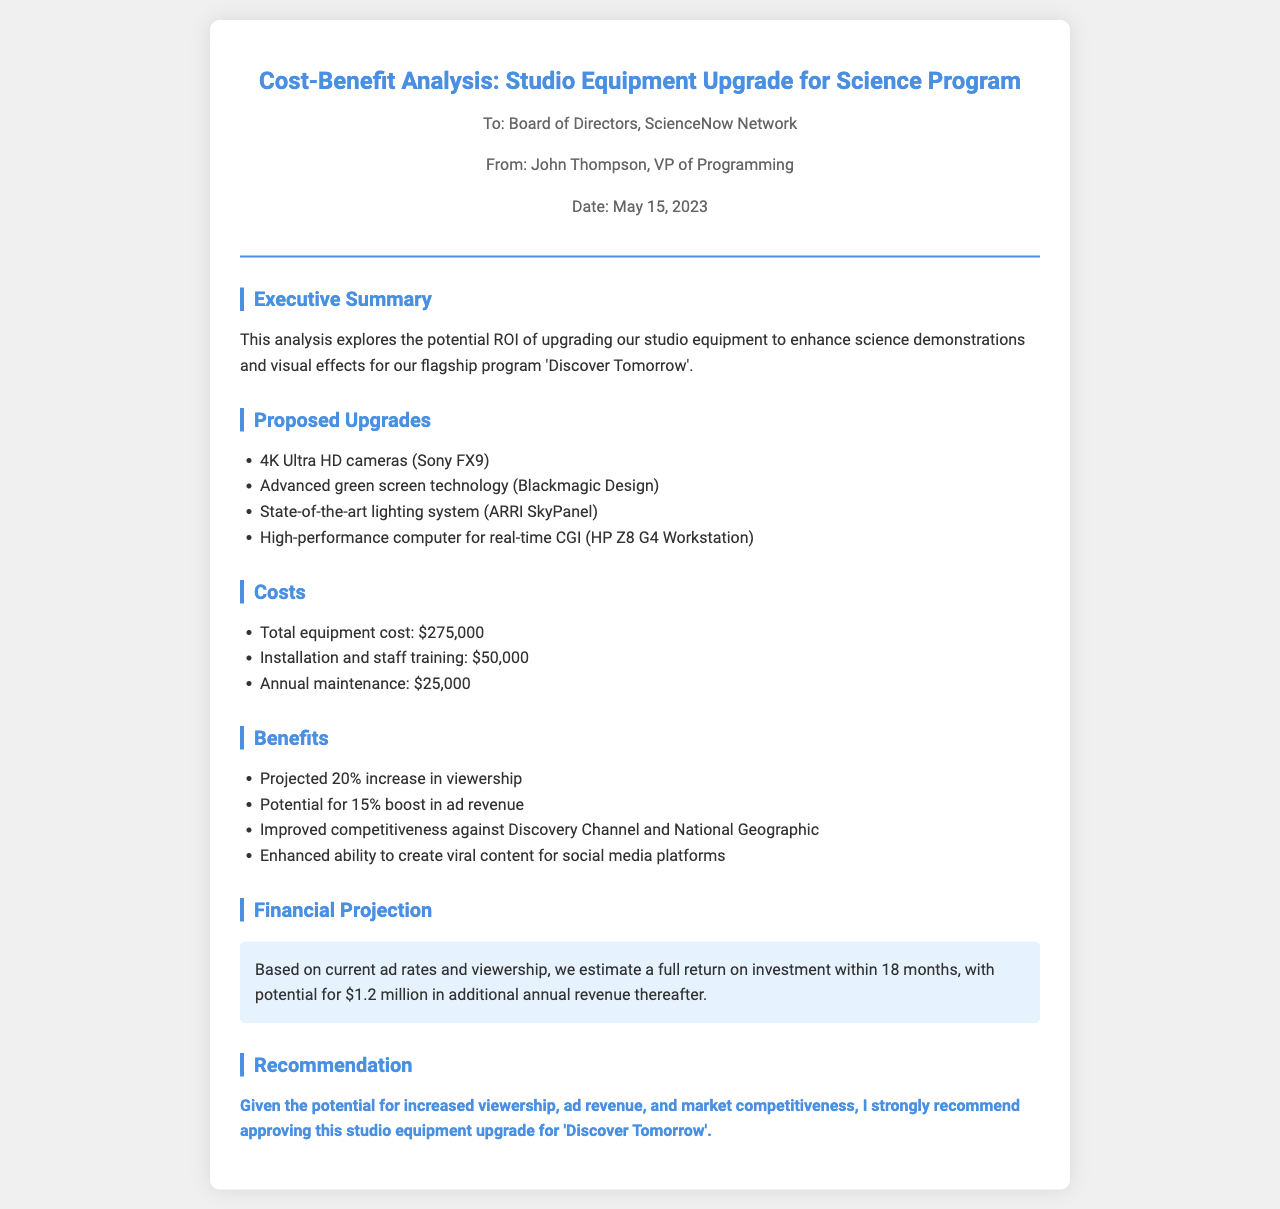what is the proposed total cost of equipment? The total equipment cost is listed explicitly in the costs section of the document.
Answer: $275,000 who is the author of the analysis? The document states the author's name in the header section.
Answer: John Thompson what is the projected percentage increase in viewership? The percentage is mentioned in the benefits section.
Answer: 20% what type of cameras are proposed for the upgrade? The specific camera model is listed in the proposed upgrades section of the document.
Answer: 4K Ultra HD cameras (Sony FX9) what is the estimated time for full return on investment? The document highlights the estimated time for full ROI in the financial projection section.
Answer: 18 months which lighting system is being proposed? The specific lighting system is mentioned in the proposed upgrades section.
Answer: ARRI SkyPanel what is the potential annual revenue increase projected? The estimated additional annual revenue is stated in the financial projection section.
Answer: $1.2 million what is the main reason for upgrading the studio equipment? The document's executive summary outlines the purpose of the upgrade.
Answer: Enhance science demonstrations and visual effects 